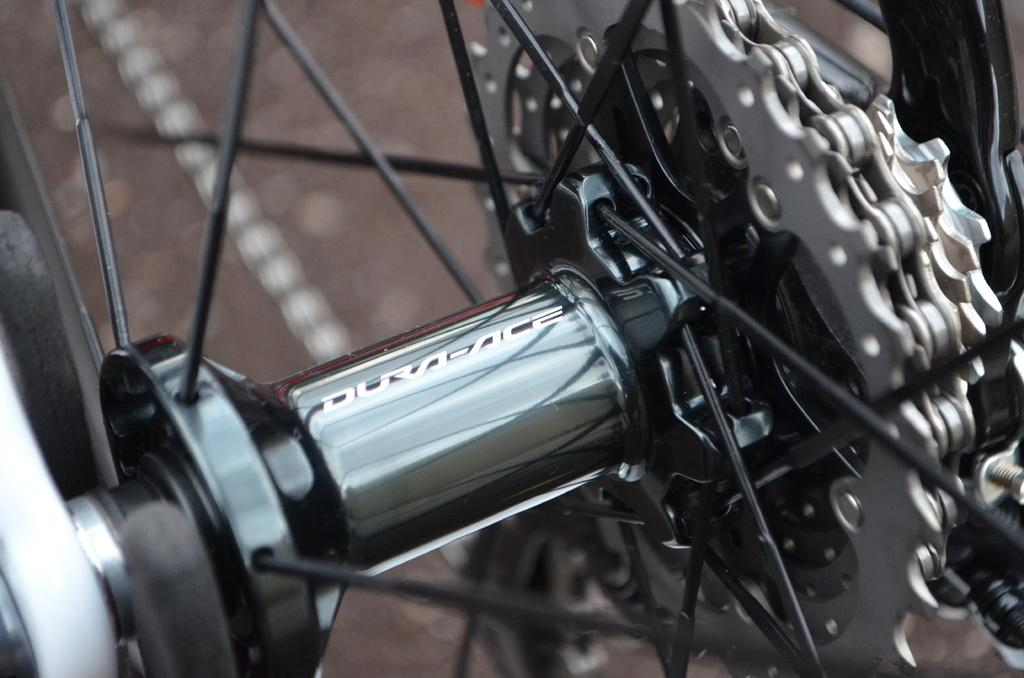What type of objects are visible in the image? There are gear plates visible in the image. How do the gear plates resemble another object? The gear plates resemble the wheel of a bicycle. What can be observed about the background of the image? The background of the image is blurred. Can you see any crows in the harbor scene depicted in the image? There is no harbor or scene in the image, and no crows are visible. 